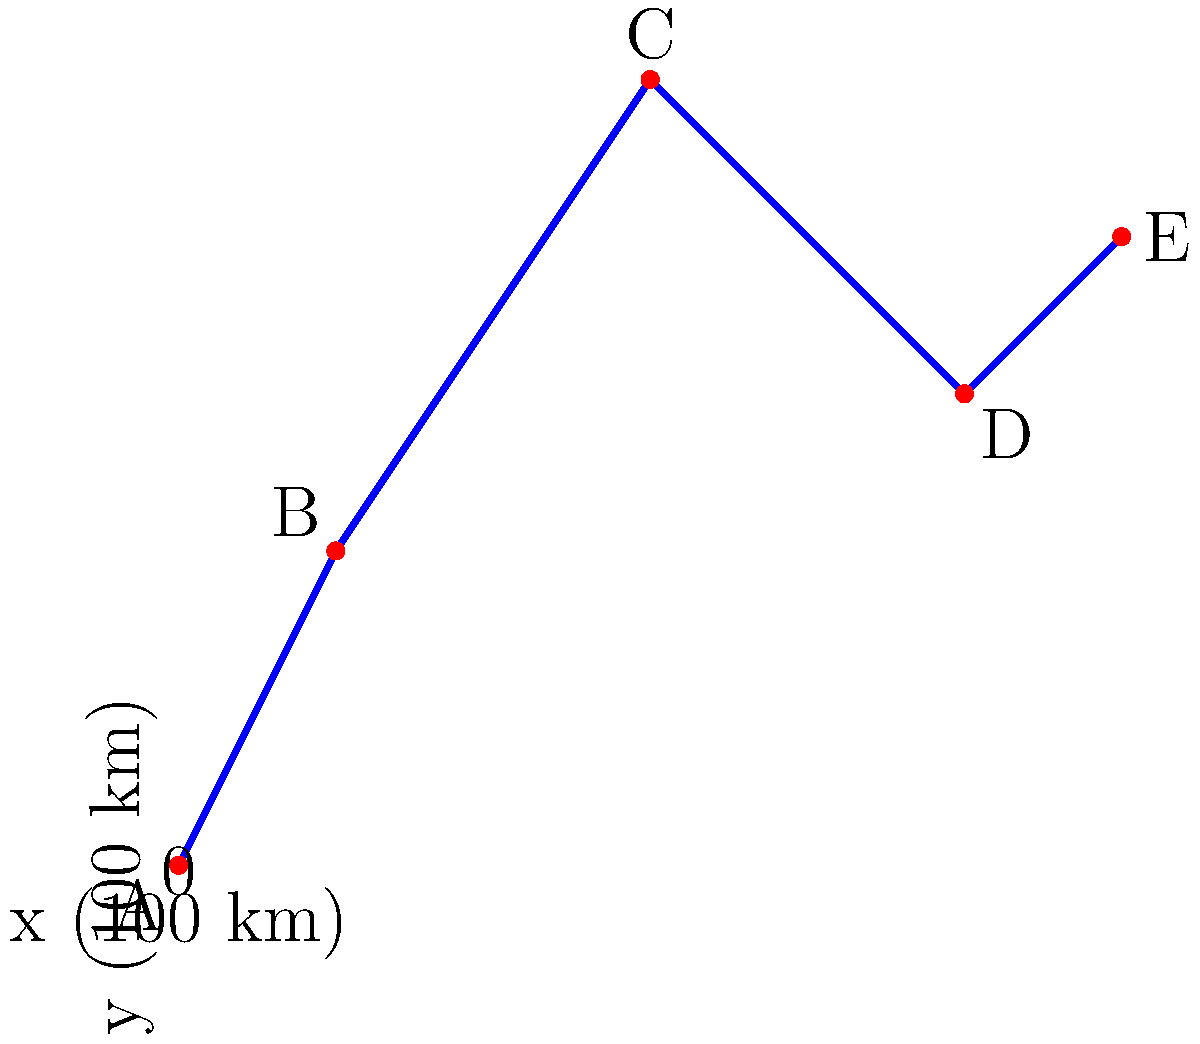The graph shows the path of your tour bus on a coordinate grid, where each unit represents 100 km. If your bus consumes 30 liters of fuel per 100 km, how many liters of fuel will be needed for the entire journey from point A to point E? To solve this problem, we need to:

1. Calculate the total distance traveled:
   - A to B: $\sqrt{(1-0)^2 + (2-0)^2} = \sqrt{5}$ units
   - B to C: $\sqrt{(3-1)^2 + (5-2)^2} = \sqrt{13}$ units
   - C to D: $\sqrt{(5-3)^2 + (3-5)^2} = \sqrt{8}$ units
   - D to E: $\sqrt{(6-5)^2 + (4-3)^2} = \sqrt{2}$ units

2. Sum up the distances:
   Total distance = $\sqrt{5} + \sqrt{13} + \sqrt{8} + \sqrt{2}$ units

3. Convert units to km:
   Total distance in km = $(\sqrt{5} + \sqrt{13} + \sqrt{8} + \sqrt{2}) \times 100$ km

4. Calculate fuel consumption:
   Fuel needed = $(\sqrt{5} + \sqrt{13} + \sqrt{8} + \sqrt{2}) \times 100 \times 30$ liters
               = $3000(\sqrt{5} + \sqrt{13} + \sqrt{8} + \sqrt{2})$ liters

5. Simplify:
   $3000(\sqrt{5} + \sqrt{13} + \sqrt{8} + \sqrt{2}) \approx 2830.97$ liters
Answer: 2831 liters 